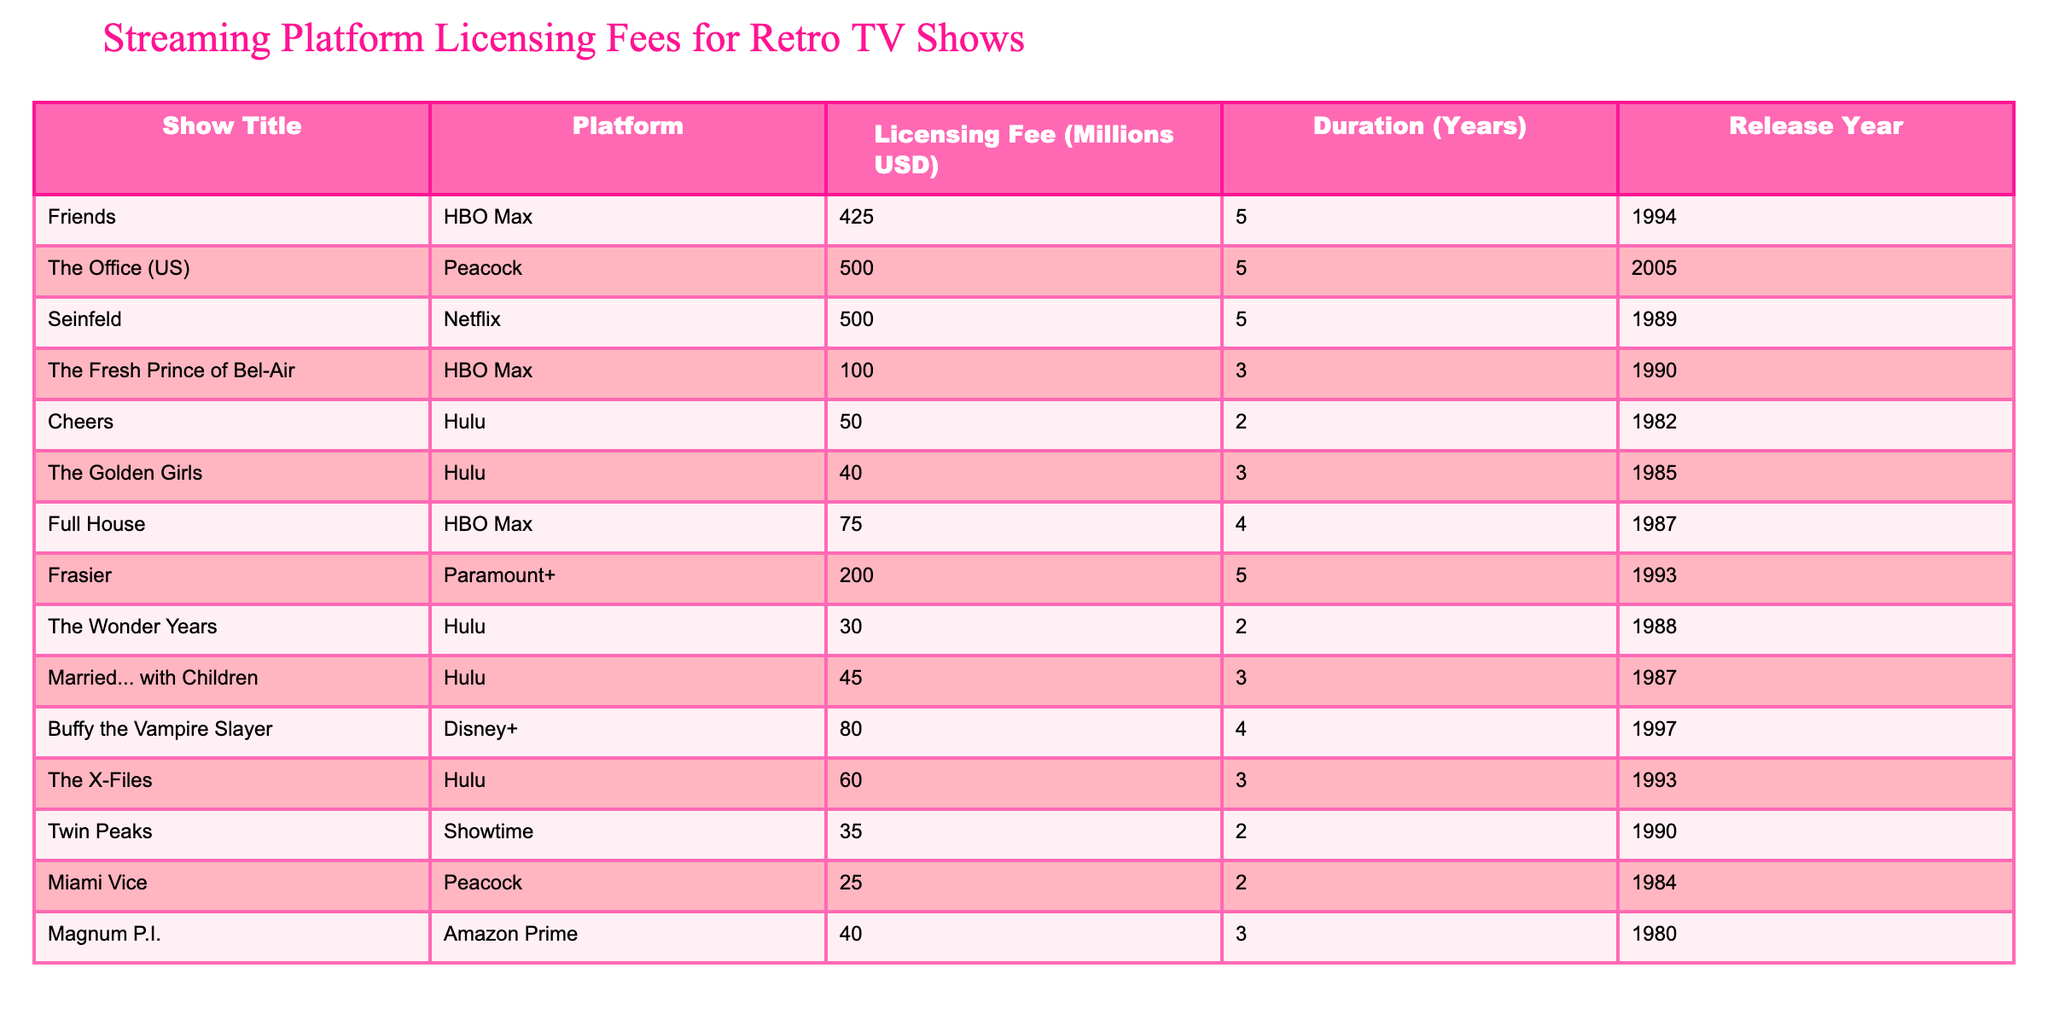What is the licensing fee for "Friends"? The table lists the licensing fee for "Friends" under the column "Licensing Fee (Millions USD)". It shows that the fee is 425 million USD.
Answer: 425 million USD Which platform has the highest licensing fee? By looking at the "Licensing Fee (Millions USD)" column, "The Office (US)" with a fee of 500 million USD has the highest value compared to other shows.
Answer: Peacock Is the duration of "Buffy the Vampire Slayer" longer than 3 years? The table states that the duration for "Buffy the Vampire Slayer" is 4 years, which is indeed longer than 3 years.
Answer: Yes What is the average licensing fee for the shows available on Hulu? To find the average licensing fee for Hulu, we calculate the sum of the fees for the shows on Hulu: (50 + 40 + 30 + 45 + 60) = 225 million USD. There are 5 shows, so the average is 225 / 5 = 45 million USD.
Answer: 45 million USD Which shows have a licensing fee less than 50 million USD? We look for the licensing fees in the "Licensing Fee (Millions USD)" column that are less than 50 million USD. These are "Cheers" (50 million USD) and "Miami Vice" (25 million USD), so "Miami Vice" qualifies.
Answer: Miami Vice What is the total licensing fee for all shows released in the 1990s? The table lists the shows from the 1990s: "Friends" (425 million), "The Fresh Prince of Bel-Air" (100 million), "Buffy the Vampire Slayer" (80 million), and "The X-Files" (60 million). The sum is 425 + 100 + 80 + 60 = 665 million USD, therefore the total is 665 million USD.
Answer: 665 million USD Does "The Golden Girls" have a licensing fee of 40 million USD? The table shows that the licensing fee for "The Golden Girls" is indeed listed as 40 million USD.
Answer: Yes Which platform has the highest total licensing fees when combining all its shows? Analyzing each platform, we sum their respective fees: HBO Max (425 + 100 + 75 = 600 million), Peacock (500 + 25 = 525 million), Netflix (500 million), Hulu (50 + 40 + 30 + 45 + 60 = 225 million), Paramount+ (200 million), and Showtime (35 million). HBO Max has the highest total at 600 million.
Answer: HBO Max 